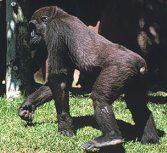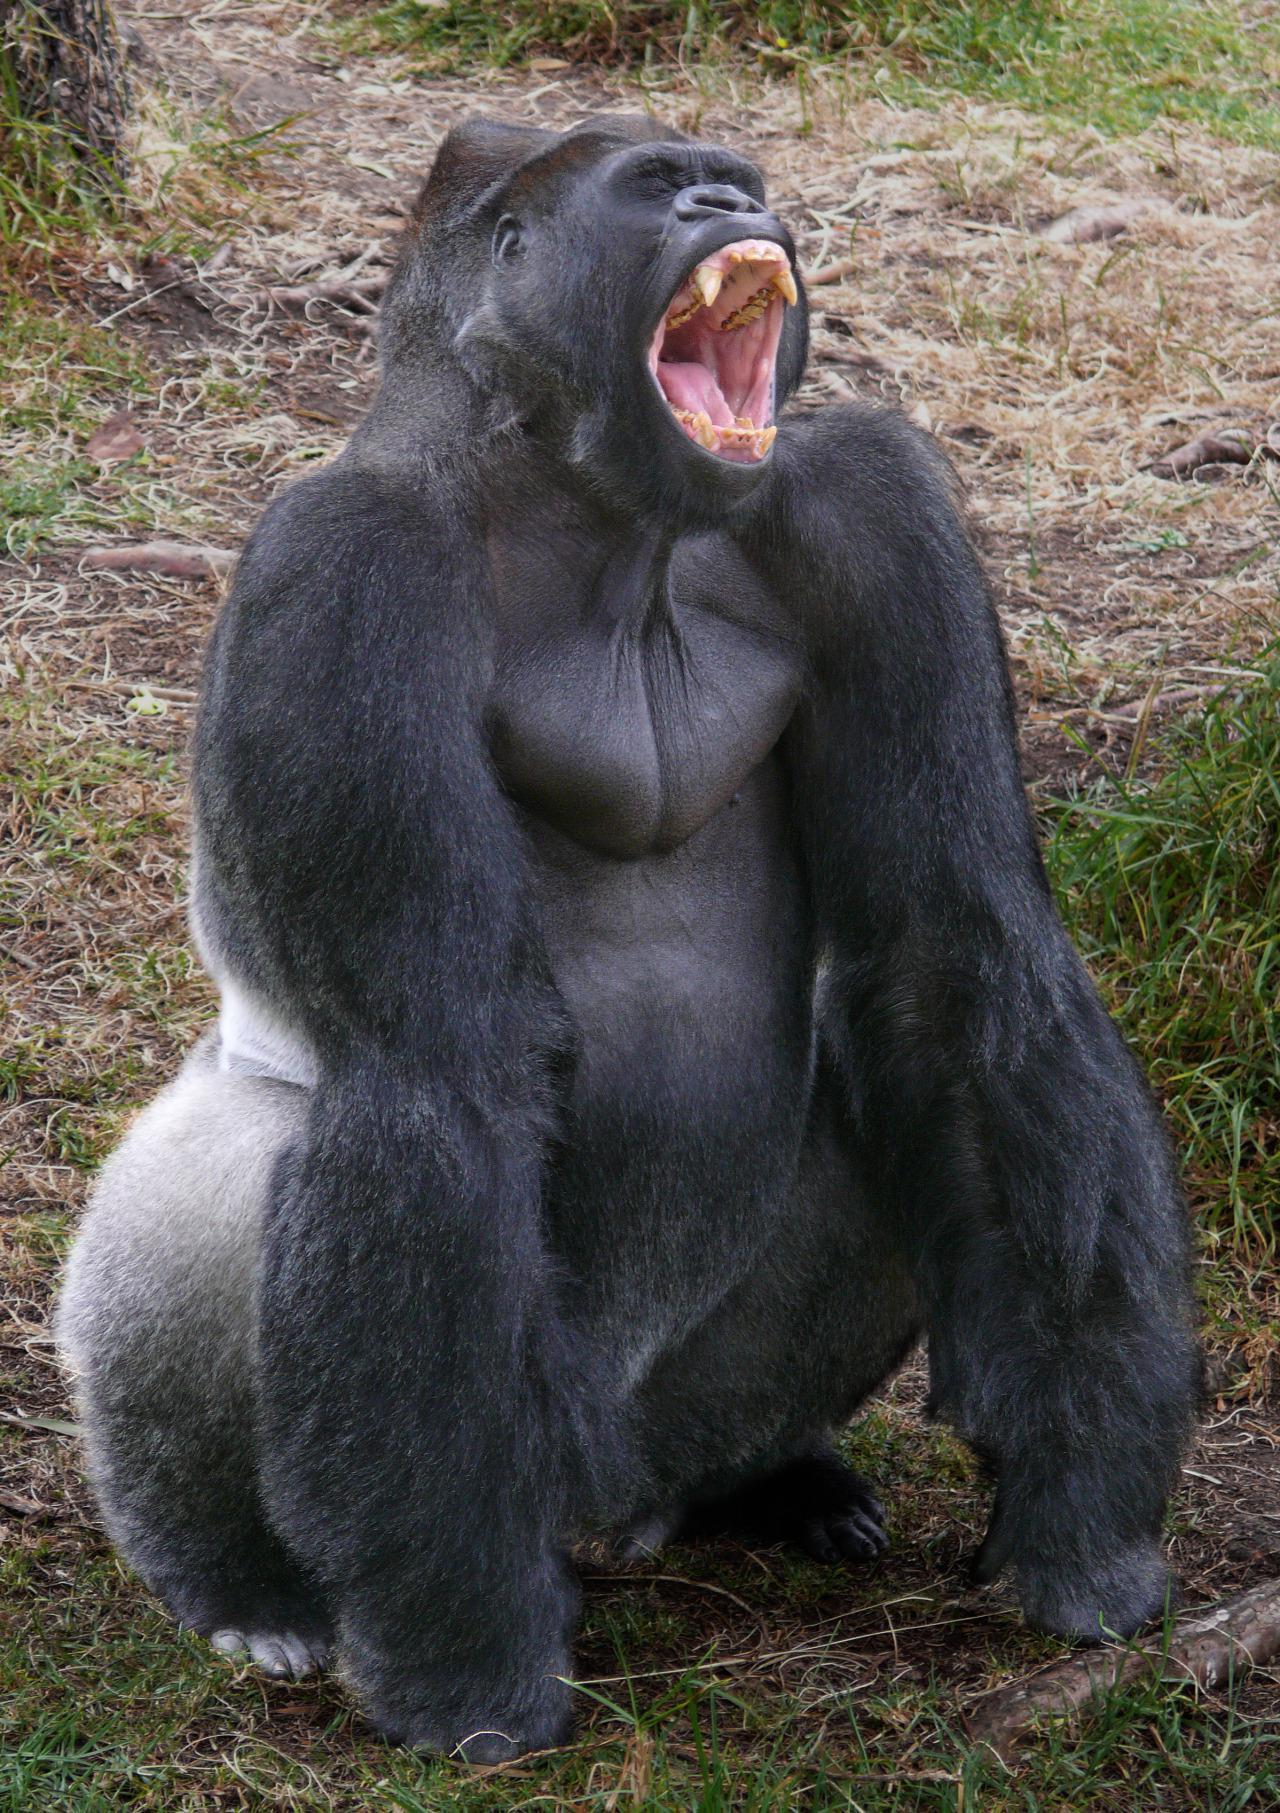The first image is the image on the left, the second image is the image on the right. For the images shown, is this caption "The ape in the image on the left is baring its teeth." true? Answer yes or no. No. 